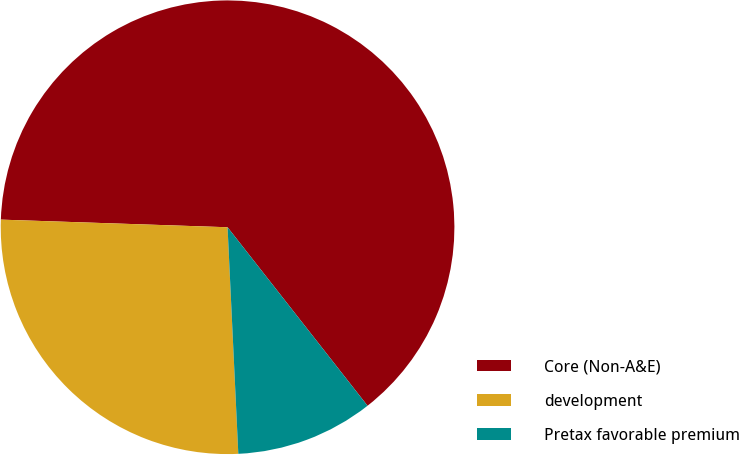Convert chart to OTSL. <chart><loc_0><loc_0><loc_500><loc_500><pie_chart><fcel>Core (Non-A&E)<fcel>development<fcel>Pretax favorable premium<nl><fcel>63.88%<fcel>26.29%<fcel>9.83%<nl></chart> 